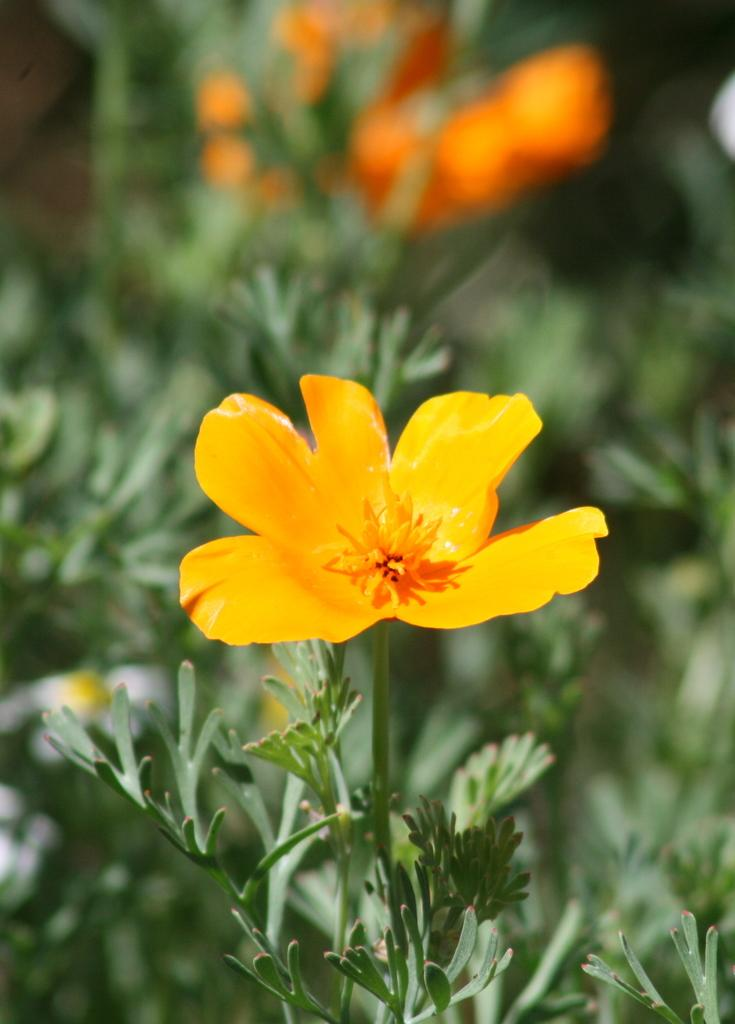What type of living organisms can be seen in the image? There are flowers and plants visible in the image. Can you describe the background of the image? The background of the image is blurred. What type of fiction is being read by the toy in the image? There is no toy or fiction present in the image; it features flowers and plants with a blurred background. 